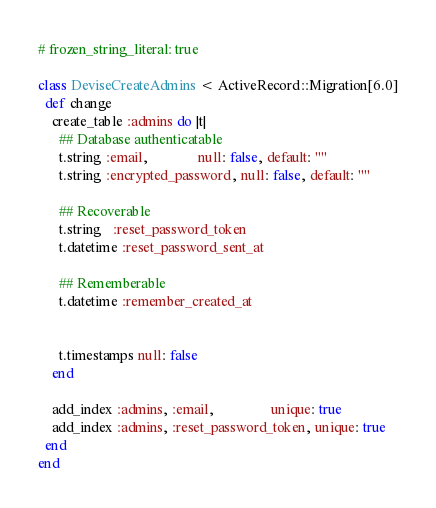<code> <loc_0><loc_0><loc_500><loc_500><_Ruby_># frozen_string_literal: true

class DeviseCreateAdmins < ActiveRecord::Migration[6.0]
  def change
    create_table :admins do |t|
      ## Database authenticatable
      t.string :email,              null: false, default: ""
      t.string :encrypted_password, null: false, default: ""

      ## Recoverable
      t.string   :reset_password_token
      t.datetime :reset_password_sent_at

      ## Rememberable
      t.datetime :remember_created_at


      t.timestamps null: false
    end

    add_index :admins, :email,                unique: true
    add_index :admins, :reset_password_token, unique: true
  end
end
</code> 